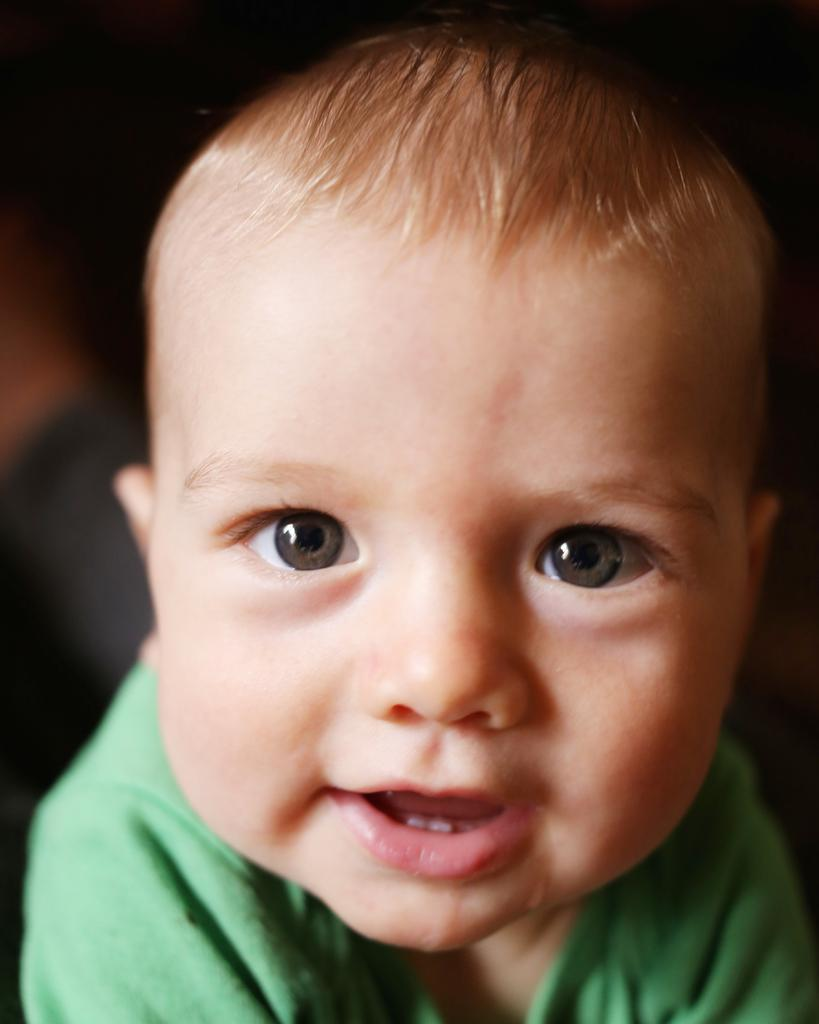Who is the main subject in the image? There is a boy in the image. What is the boy's facial expression? The boy is smiling. Can you describe the background of the image? The background of the image is blurred. What type of answer is the boy holding in the image? There is no answer visible in the image; the boy is simply smiling. 